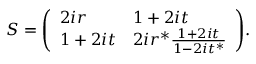Convert formula to latex. <formula><loc_0><loc_0><loc_500><loc_500>S = { \left ( \begin{array} { l l } { 2 i r } & { 1 + 2 i t } \\ { 1 + 2 i t } & { 2 i r ^ { * } { \frac { 1 + 2 i t } { 1 - 2 i t ^ { * } } } } \end{array} \right ) } .</formula> 